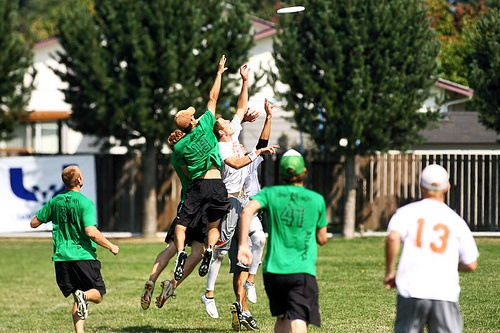Describe the objects in this image and their specific colors. I can see people in darkgreen, white, black, darkgray, and gray tones, people in darkgreen, black, lightgreen, and green tones, people in darkgreen, black, olive, and green tones, people in darkgreen, black, tan, green, and lightgreen tones, and people in darkgreen, white, darkgray, gray, and tan tones in this image. 